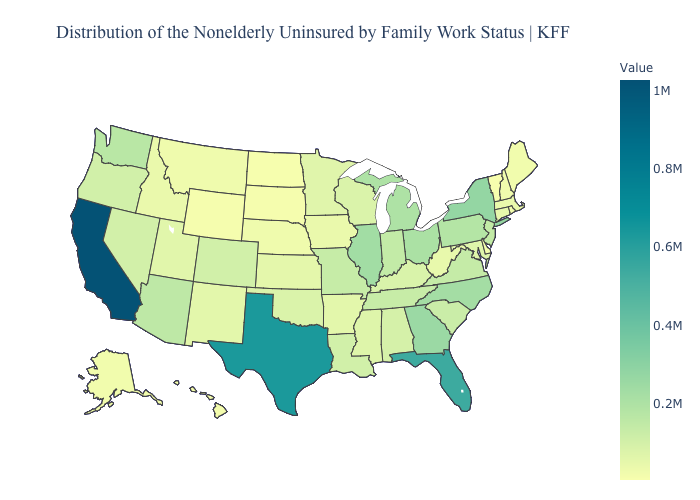Which states have the lowest value in the West?
Quick response, please. Wyoming. Among the states that border Nebraska , does South Dakota have the highest value?
Quick response, please. No. Does Vermont have the lowest value in the USA?
Write a very short answer. Yes. Does New Hampshire have the highest value in the Northeast?
Short answer required. No. Among the states that border Nebraska , which have the lowest value?
Answer briefly. South Dakota. Does Arizona have the lowest value in the West?
Keep it brief. No. 